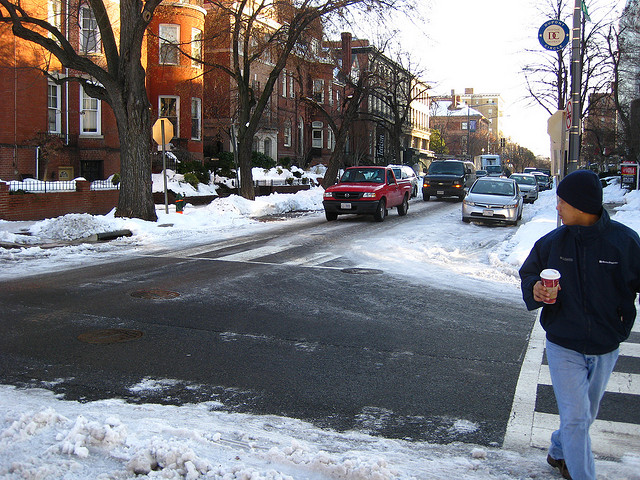<image>What is the name of the company selling the house? It is unclear what the name of the company selling the house is. It could be 'remax', 'realty', 'exit', 'century 21', or 'long and foster'. What is the name of the company selling the house? The name of the company selling the house is unknown. However, it can be seen as 'remax', 'realty', 'exit', 'century 21', or 'long and foster'. 